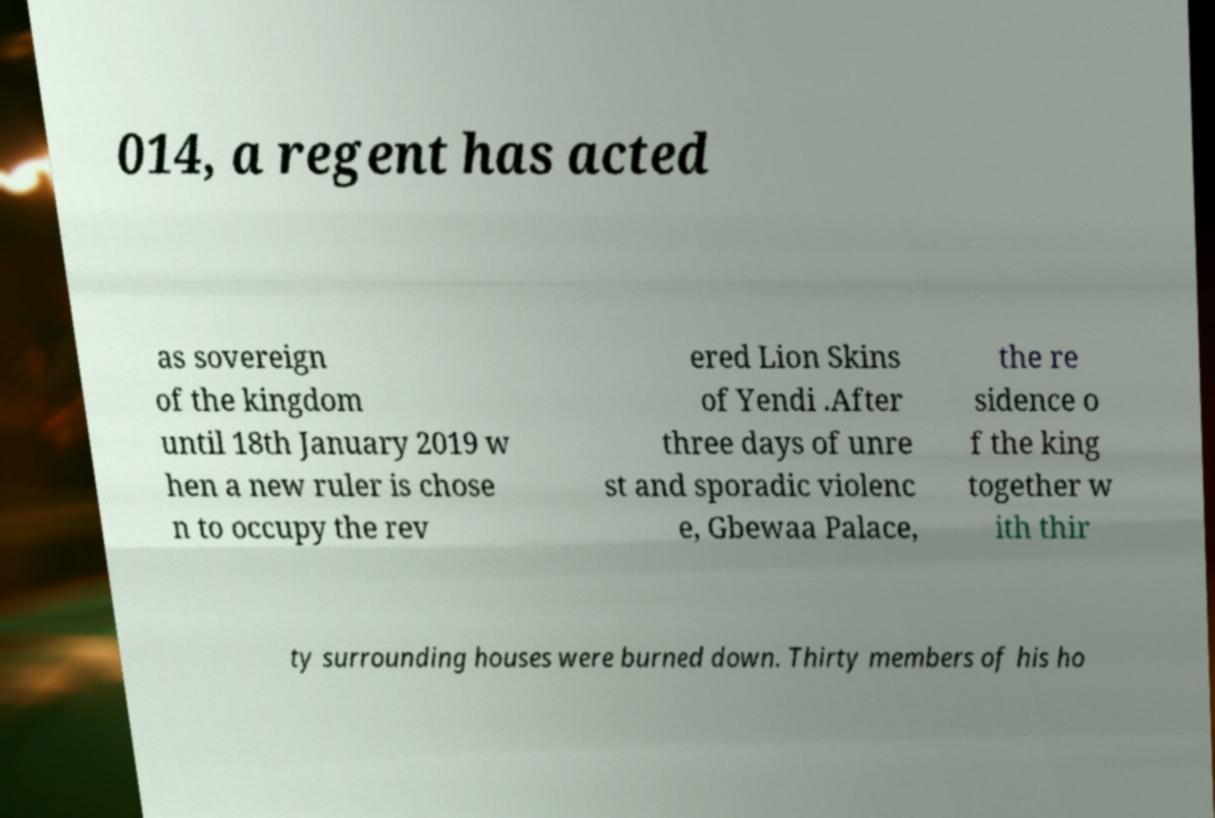Could you assist in decoding the text presented in this image and type it out clearly? 014, a regent has acted as sovereign of the kingdom until 18th January 2019 w hen a new ruler is chose n to occupy the rev ered Lion Skins of Yendi .After three days of unre st and sporadic violenc e, Gbewaa Palace, the re sidence o f the king together w ith thir ty surrounding houses were burned down. Thirty members of his ho 